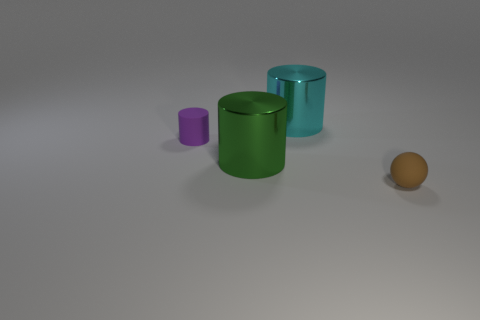Add 4 tiny red metal spheres. How many objects exist? 8 Subtract all cylinders. How many objects are left? 1 Add 1 purple things. How many purple things are left? 2 Add 4 tiny purple cylinders. How many tiny purple cylinders exist? 5 Subtract 0 blue blocks. How many objects are left? 4 Subtract all purple cylinders. Subtract all brown rubber objects. How many objects are left? 2 